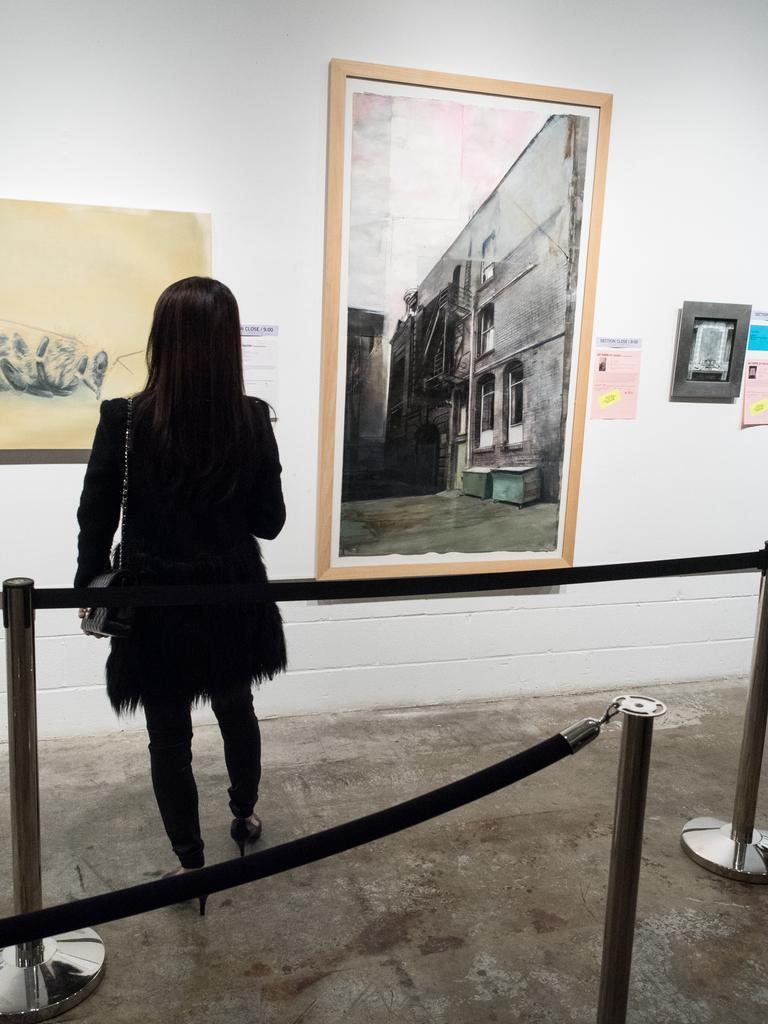How would you summarize this image in a sentence or two? In this picture we can see a few rods and ropes from left to right. There is a woman wearing a bag and standing on the ground. We can see a few frames and posters on the wall. 